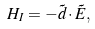Convert formula to latex. <formula><loc_0><loc_0><loc_500><loc_500>H _ { I } = - \vec { d } \cdot \vec { E } ,</formula> 